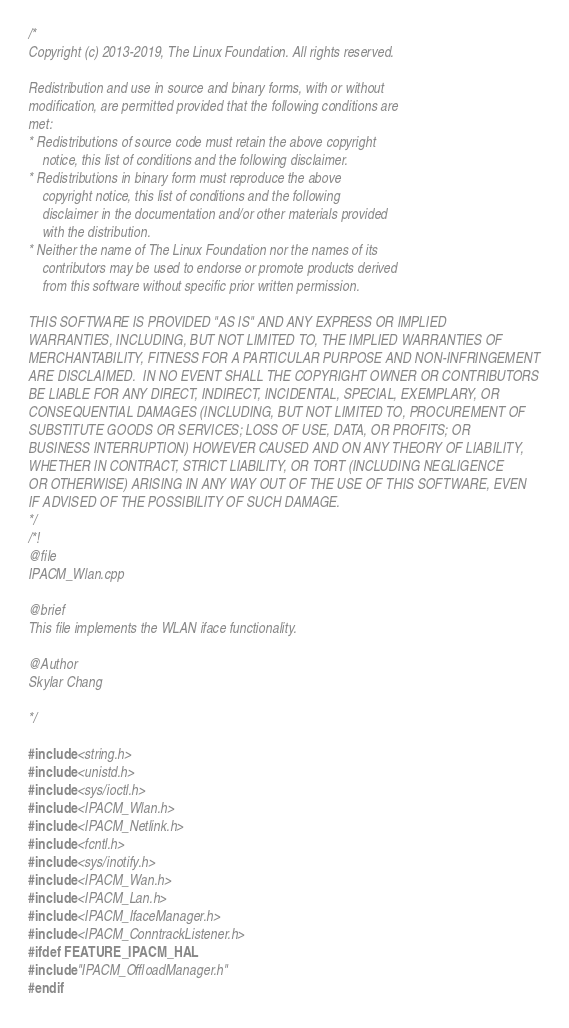Convert code to text. <code><loc_0><loc_0><loc_500><loc_500><_C++_>/*
Copyright (c) 2013-2019, The Linux Foundation. All rights reserved.

Redistribution and use in source and binary forms, with or without
modification, are permitted provided that the following conditions are
met:
* Redistributions of source code must retain the above copyright
	notice, this list of conditions and the following disclaimer.
* Redistributions in binary form must reproduce the above
	copyright notice, this list of conditions and the following
	disclaimer in the documentation and/or other materials provided
	with the distribution.
* Neither the name of The Linux Foundation nor the names of its
	contributors may be used to endorse or promote products derived
	from this software without specific prior written permission.

THIS SOFTWARE IS PROVIDED "AS IS" AND ANY EXPRESS OR IMPLIED
WARRANTIES, INCLUDING, BUT NOT LIMITED TO, THE IMPLIED WARRANTIES OF
MERCHANTABILITY, FITNESS FOR A PARTICULAR PURPOSE AND NON-INFRINGEMENT
ARE DISCLAIMED.  IN NO EVENT SHALL THE COPYRIGHT OWNER OR CONTRIBUTORS
BE LIABLE FOR ANY DIRECT, INDIRECT, INCIDENTAL, SPECIAL, EXEMPLARY, OR
CONSEQUENTIAL DAMAGES (INCLUDING, BUT NOT LIMITED TO, PROCUREMENT OF
SUBSTITUTE GOODS OR SERVICES; LOSS OF USE, DATA, OR PROFITS; OR
BUSINESS INTERRUPTION) HOWEVER CAUSED AND ON ANY THEORY OF LIABILITY,
WHETHER IN CONTRACT, STRICT LIABILITY, OR TORT (INCLUDING NEGLIGENCE
OR OTHERWISE) ARISING IN ANY WAY OUT OF THE USE OF THIS SOFTWARE, EVEN
IF ADVISED OF THE POSSIBILITY OF SUCH DAMAGE.
*/
/*!
@file
IPACM_Wlan.cpp

@brief
This file implements the WLAN iface functionality.

@Author
Skylar Chang

*/

#include <string.h>
#include <unistd.h>
#include <sys/ioctl.h>
#include <IPACM_Wlan.h>
#include <IPACM_Netlink.h>
#include <fcntl.h>
#include <sys/inotify.h>
#include <IPACM_Wan.h>
#include <IPACM_Lan.h>
#include <IPACM_IfaceManager.h>
#include <IPACM_ConntrackListener.h>
#ifdef FEATURE_IPACM_HAL
#include "IPACM_OffloadManager.h"
#endif
</code> 